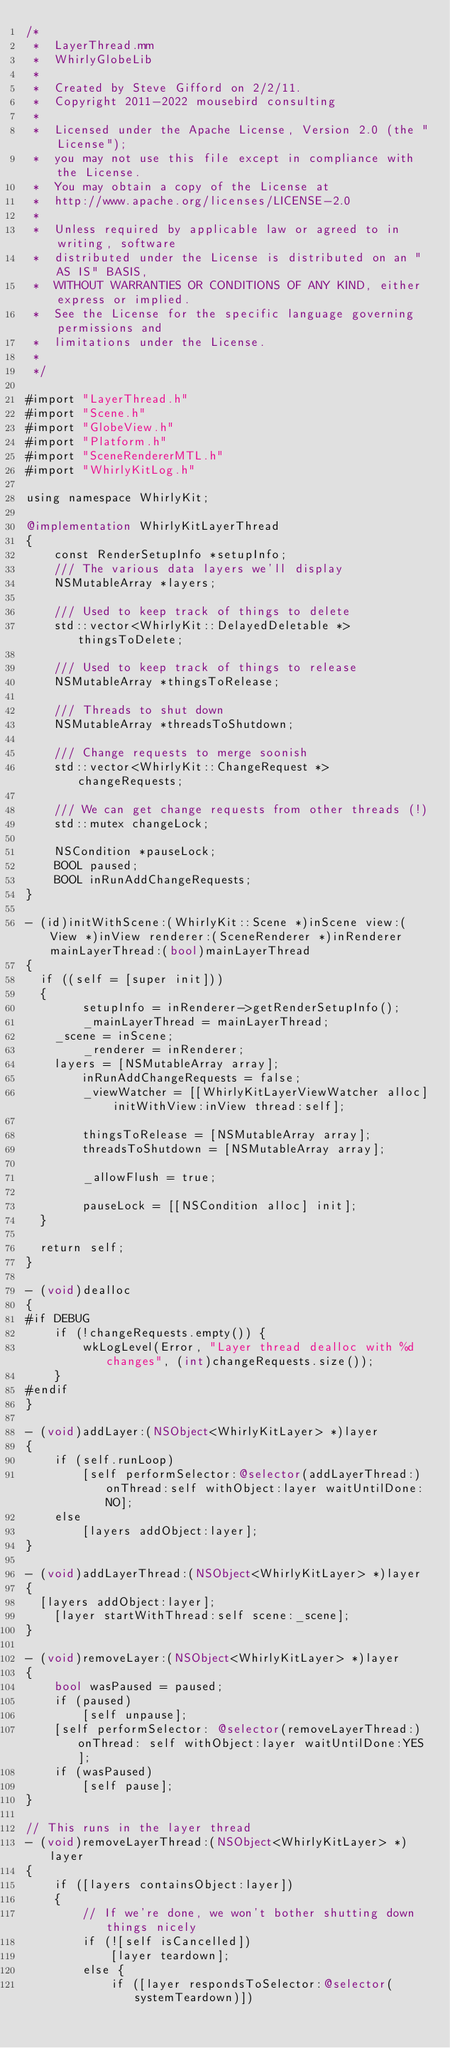Convert code to text. <code><loc_0><loc_0><loc_500><loc_500><_ObjectiveC_>/*
 *  LayerThread.mm
 *  WhirlyGlobeLib
 *
 *  Created by Steve Gifford on 2/2/11.
 *  Copyright 2011-2022 mousebird consulting
 *
 *  Licensed under the Apache License, Version 2.0 (the "License");
 *  you may not use this file except in compliance with the License.
 *  You may obtain a copy of the License at
 *  http://www.apache.org/licenses/LICENSE-2.0
 *
 *  Unless required by applicable law or agreed to in writing, software
 *  distributed under the License is distributed on an "AS IS" BASIS,
 *  WITHOUT WARRANTIES OR CONDITIONS OF ANY KIND, either express or implied.
 *  See the License for the specific language governing permissions and
 *  limitations under the License.
 *
 */

#import "LayerThread.h"
#import "Scene.h"
#import "GlobeView.h"
#import "Platform.h"
#import "SceneRendererMTL.h"
#import "WhirlyKitLog.h"

using namespace WhirlyKit;

@implementation WhirlyKitLayerThread
{
    const RenderSetupInfo *setupInfo;
    /// The various data layers we'll display
    NSMutableArray *layers;
    
    /// Used to keep track of things to delete
    std::vector<WhirlyKit::DelayedDeletable *> thingsToDelete;
    
    /// Used to keep track of things to release
    NSMutableArray *thingsToRelease;
    
    /// Threads to shut down
    NSMutableArray *threadsToShutdown;
    
    /// Change requests to merge soonish
    std::vector<WhirlyKit::ChangeRequest *> changeRequests;
    
    /// We can get change requests from other threads (!)
    std::mutex changeLock;
    
    NSCondition *pauseLock;
    BOOL paused;
    BOOL inRunAddChangeRequests;
}

- (id)initWithScene:(WhirlyKit::Scene *)inScene view:(View *)inView renderer:(SceneRenderer *)inRenderer mainLayerThread:(bool)mainLayerThread
{
	if ((self = [super init]))
	{
        setupInfo = inRenderer->getRenderSetupInfo();
        _mainLayerThread = mainLayerThread;
		_scene = inScene;
        _renderer = inRenderer;
		layers = [NSMutableArray array];
        inRunAddChangeRequests = false;
        _viewWatcher = [[WhirlyKitLayerViewWatcher alloc] initWithView:inView thread:self];
        
        thingsToRelease = [NSMutableArray array];
        threadsToShutdown = [NSMutableArray array];
        
        _allowFlush = true;
        
        pauseLock = [[NSCondition alloc] init];
	}
	
	return self;
}

- (void)dealloc
{
#if DEBUG
    if (!changeRequests.empty()) {
        wkLogLevel(Error, "Layer thread dealloc with %d changes", (int)changeRequests.size());
    }
#endif
}

- (void)addLayer:(NSObject<WhirlyKitLayer> *)layer
{
    if (self.runLoop)
        [self performSelector:@selector(addLayerThread:) onThread:self withObject:layer waitUntilDone:NO];
    else
        [layers addObject:layer];    
}

- (void)addLayerThread:(NSObject<WhirlyKitLayer> *)layer
{
	[layers addObject:layer];    
    [layer startWithThread:self scene:_scene];
}

- (void)removeLayer:(NSObject<WhirlyKitLayer> *)layer
{
    bool wasPaused = paused;
    if (paused)
        [self unpause];
    [self performSelector: @selector(removeLayerThread:) onThread: self withObject:layer waitUntilDone:YES];
    if (wasPaused)
        [self pause];
}

// This runs in the layer thread
- (void)removeLayerThread:(NSObject<WhirlyKitLayer> *)layer
{
    if ([layers containsObject:layer])
    {
        // If we're done, we won't bother shutting down things nicely
        if (![self isCancelled])
            [layer teardown];
        else {
            if ([layer respondsToSelector:@selector(systemTeardown)])</code> 